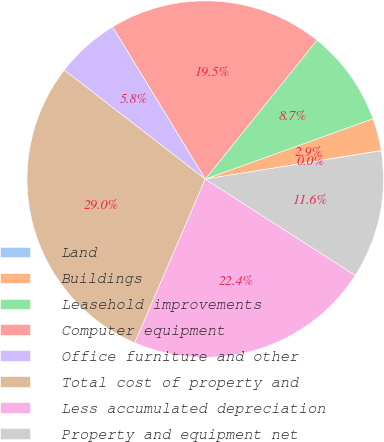Convert chart to OTSL. <chart><loc_0><loc_0><loc_500><loc_500><pie_chart><fcel>Land<fcel>Buildings<fcel>Leasehold improvements<fcel>Computer equipment<fcel>Office furniture and other<fcel>Total cost of property and<fcel>Less accumulated depreciation<fcel>Property and equipment net<nl><fcel>0.03%<fcel>2.93%<fcel>8.72%<fcel>19.49%<fcel>5.82%<fcel>29.0%<fcel>22.39%<fcel>11.62%<nl></chart> 